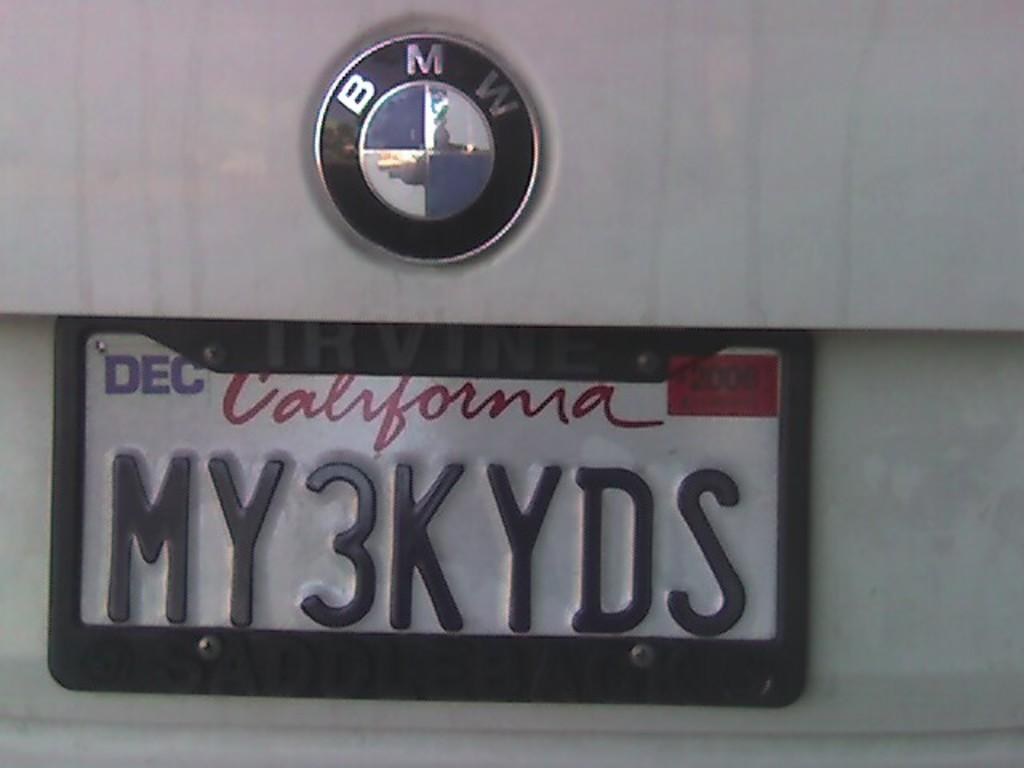<image>
Provide a brief description of the given image. A white BMW with a California tag that reads MY3KYDS. 